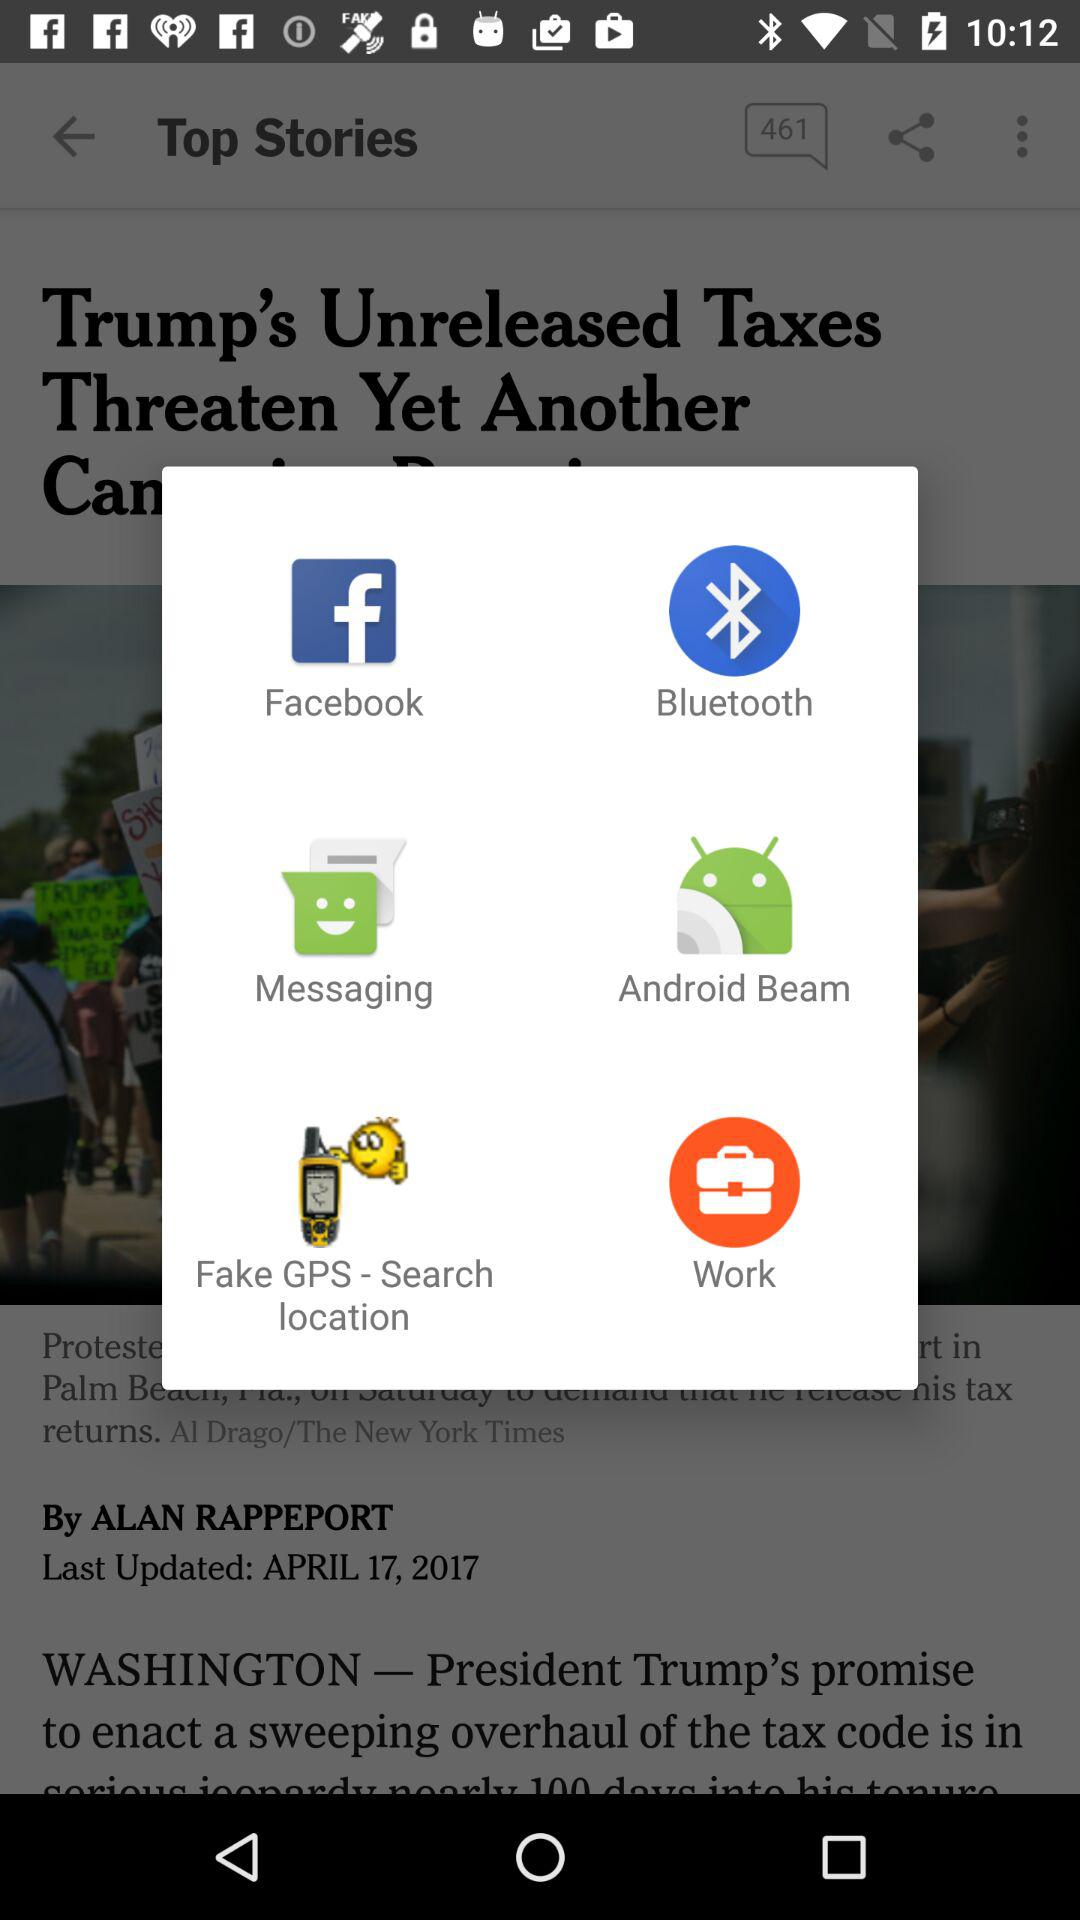Through what apps can I share? You can share through Facebook, Bluetooth, Messaging, Android Beam, Fake GPS - Search location and Work. 